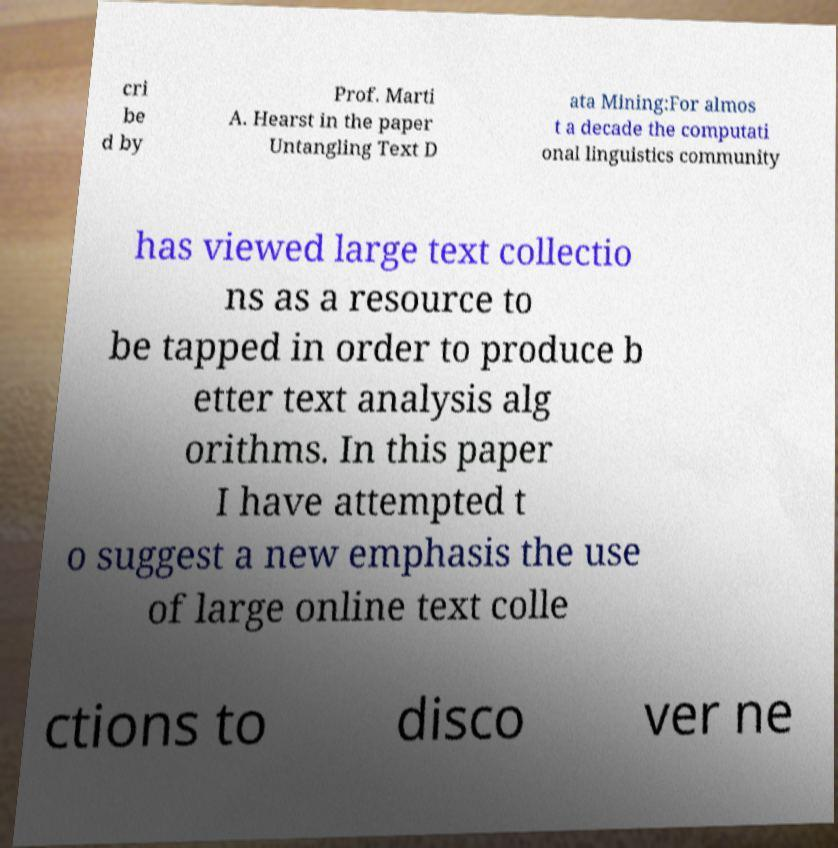Could you extract and type out the text from this image? cri be d by Prof. Marti A. Hearst in the paper Untangling Text D ata Mining:For almos t a decade the computati onal linguistics community has viewed large text collectio ns as a resource to be tapped in order to produce b etter text analysis alg orithms. In this paper I have attempted t o suggest a new emphasis the use of large online text colle ctions to disco ver ne 